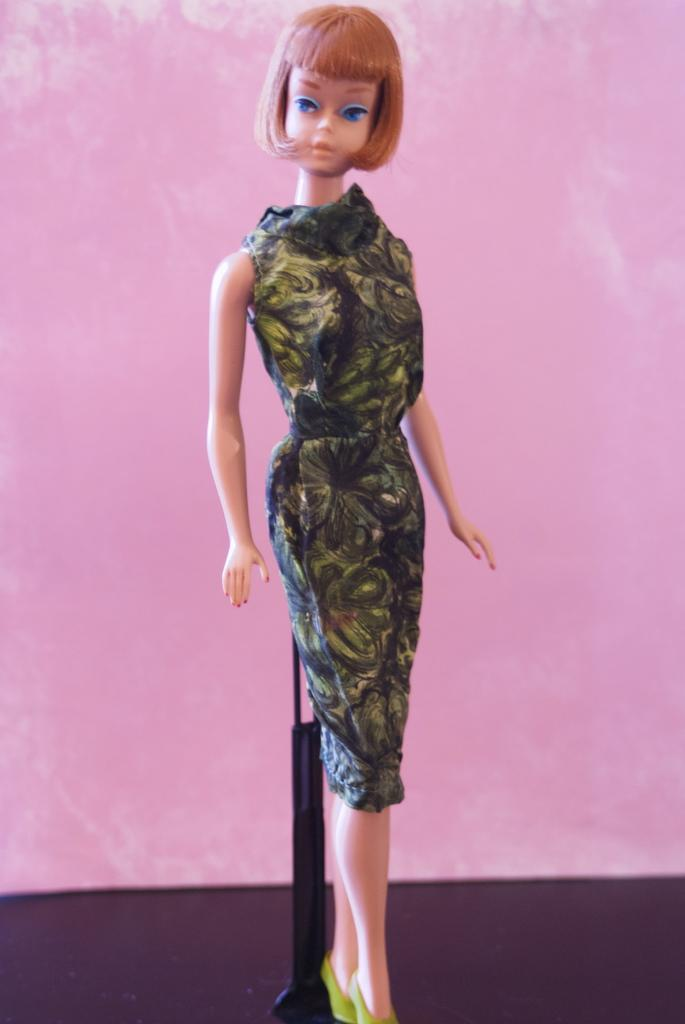What is the main subject of the image? There is a doll in the image. Where is the doll located? The doll is on a surface. What is behind the doll? There is a stand behind the doll. What color is the wall in the background of the image? The wall in the background of the image is pink. What type of wound can be seen on the doll's face in the image? There is no wound visible on the doll's face in the image. What magical substance is being used to animate the doll in the image? There is no indication of magic or any magical substance in the image; it simply shows a doll on a surface with a stand behind it. 